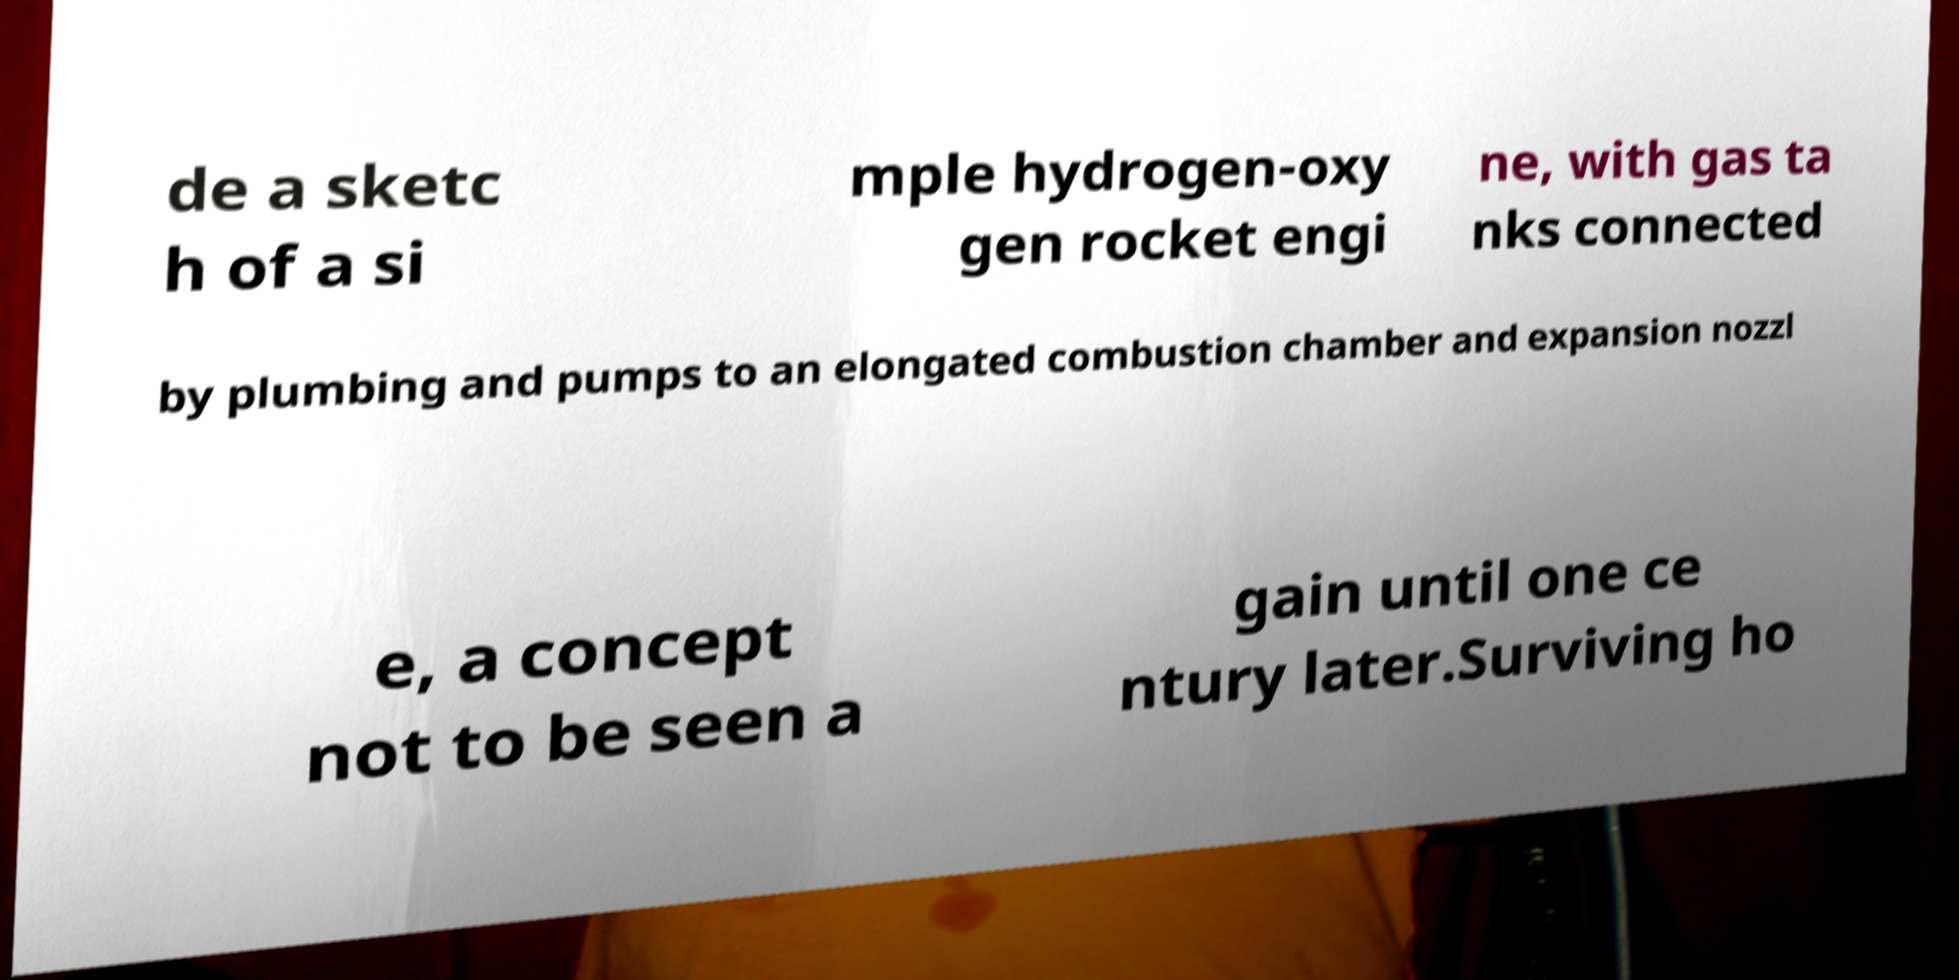Can you accurately transcribe the text from the provided image for me? de a sketc h of a si mple hydrogen-oxy gen rocket engi ne, with gas ta nks connected by plumbing and pumps to an elongated combustion chamber and expansion nozzl e, a concept not to be seen a gain until one ce ntury later.Surviving ho 